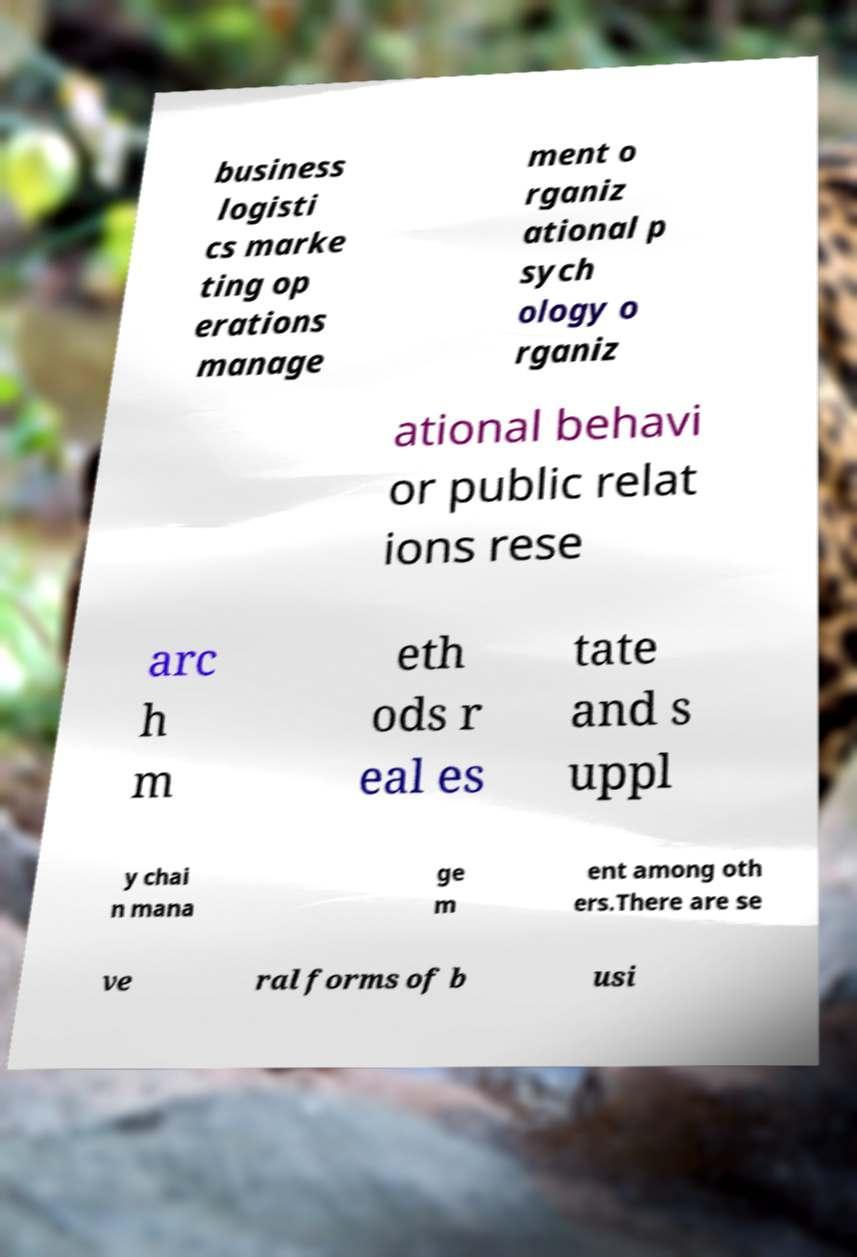Please identify and transcribe the text found in this image. business logisti cs marke ting op erations manage ment o rganiz ational p sych ology o rganiz ational behavi or public relat ions rese arc h m eth ods r eal es tate and s uppl y chai n mana ge m ent among oth ers.There are se ve ral forms of b usi 